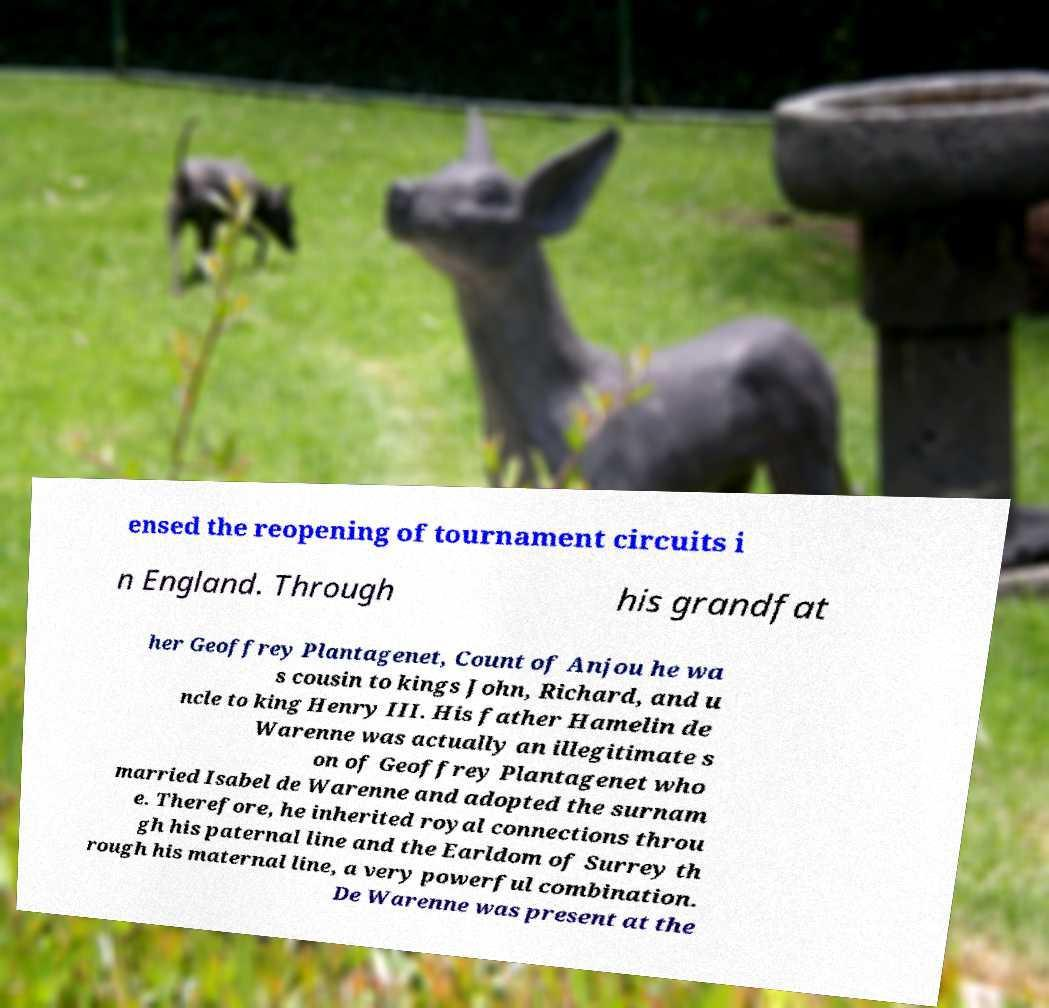Could you assist in decoding the text presented in this image and type it out clearly? ensed the reopening of tournament circuits i n England. Through his grandfat her Geoffrey Plantagenet, Count of Anjou he wa s cousin to kings John, Richard, and u ncle to king Henry III. His father Hamelin de Warenne was actually an illegitimate s on of Geoffrey Plantagenet who married Isabel de Warenne and adopted the surnam e. Therefore, he inherited royal connections throu gh his paternal line and the Earldom of Surrey th rough his maternal line, a very powerful combination. De Warenne was present at the 